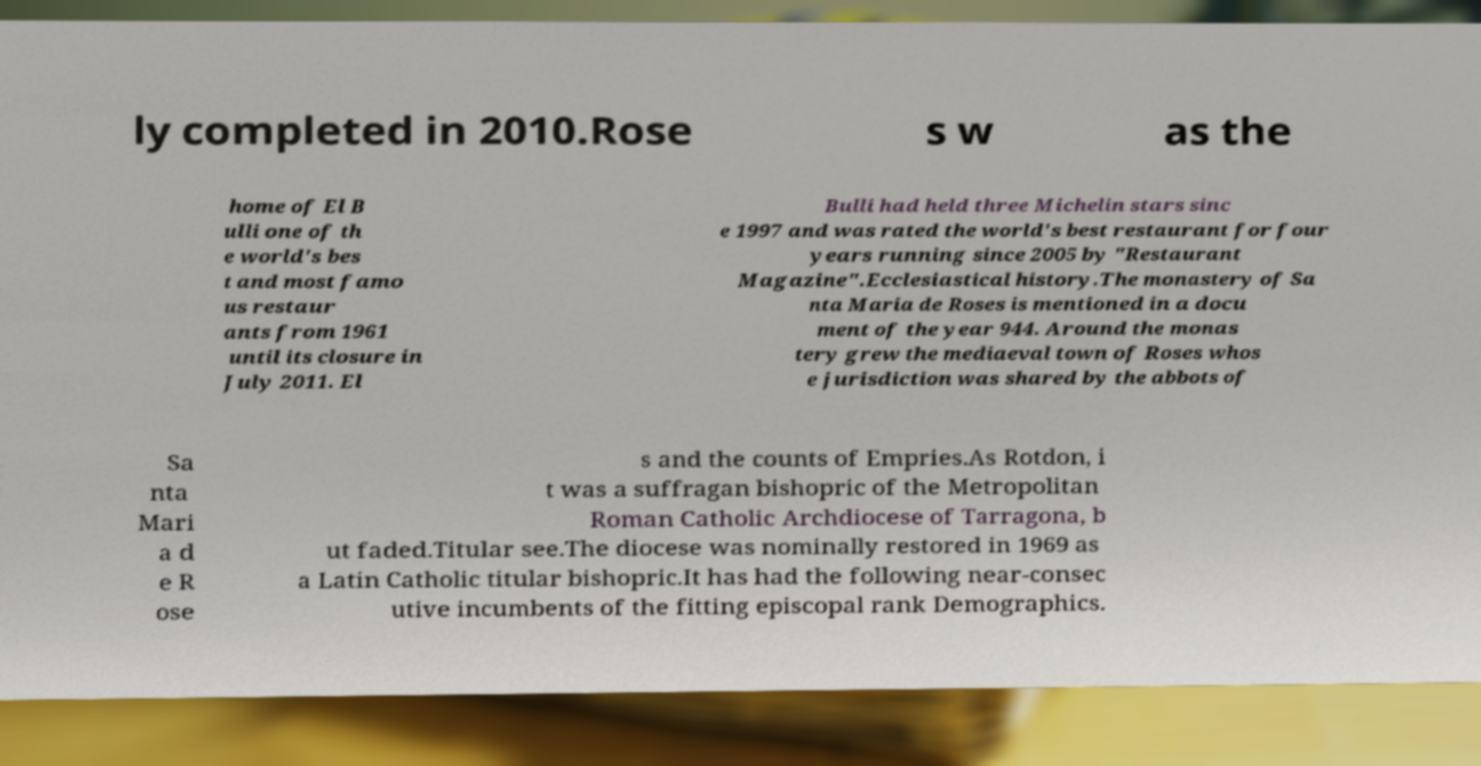Could you assist in decoding the text presented in this image and type it out clearly? ly completed in 2010.Rose s w as the home of El B ulli one of th e world's bes t and most famo us restaur ants from 1961 until its closure in July 2011. El Bulli had held three Michelin stars sinc e 1997 and was rated the world's best restaurant for four years running since 2005 by "Restaurant Magazine".Ecclesiastical history.The monastery of Sa nta Maria de Roses is mentioned in a docu ment of the year 944. Around the monas tery grew the mediaeval town of Roses whos e jurisdiction was shared by the abbots of Sa nta Mari a d e R ose s and the counts of Empries.As Rotdon, i t was a suffragan bishopric of the Metropolitan Roman Catholic Archdiocese of Tarragona, b ut faded.Titular see.The diocese was nominally restored in 1969 as a Latin Catholic titular bishopric.It has had the following near-consec utive incumbents of the fitting episcopal rank Demographics. 